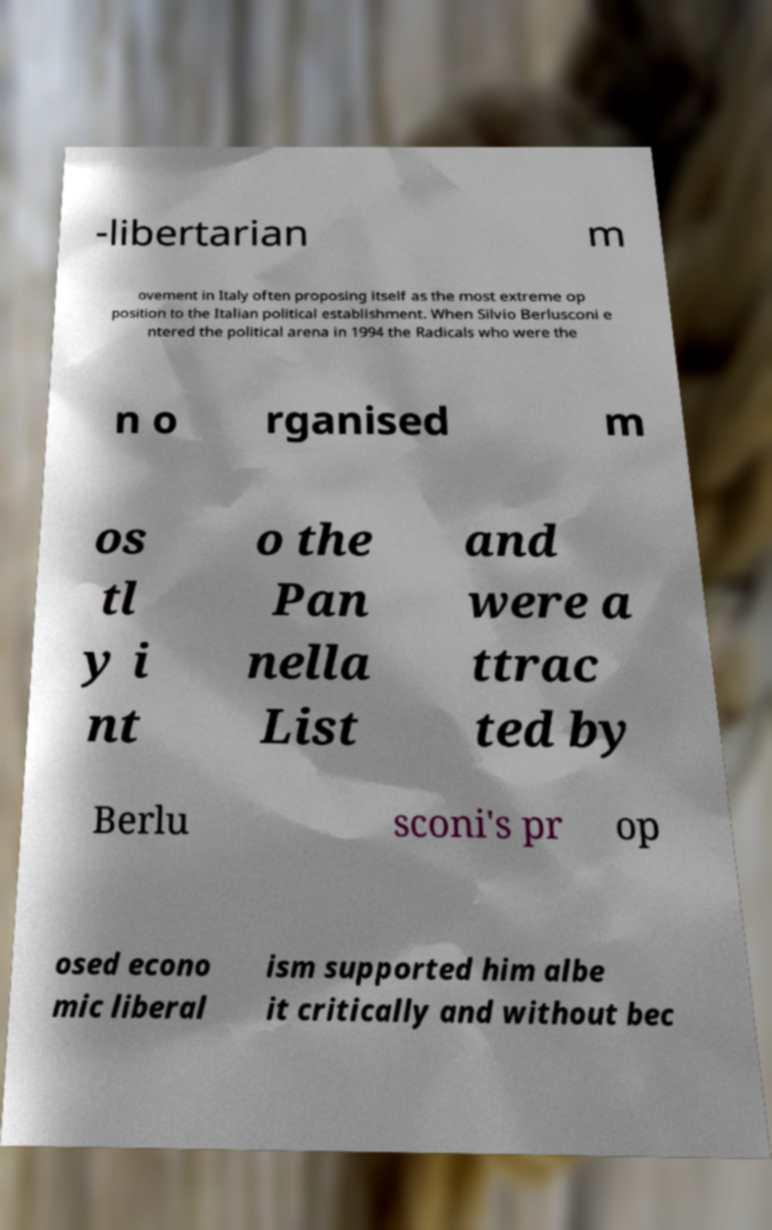What messages or text are displayed in this image? I need them in a readable, typed format. -libertarian m ovement in Italy often proposing itself as the most extreme op position to the Italian political establishment. When Silvio Berlusconi e ntered the political arena in 1994 the Radicals who were the n o rganised m os tl y i nt o the Pan nella List and were a ttrac ted by Berlu sconi's pr op osed econo mic liberal ism supported him albe it critically and without bec 